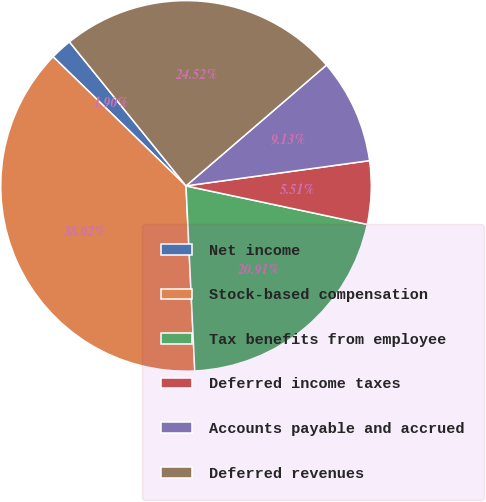Convert chart to OTSL. <chart><loc_0><loc_0><loc_500><loc_500><pie_chart><fcel>Net income<fcel>Stock-based compensation<fcel>Tax benefits from employee<fcel>Deferred income taxes<fcel>Accounts payable and accrued<fcel>Deferred revenues<nl><fcel>1.9%<fcel>38.02%<fcel>20.91%<fcel>5.51%<fcel>9.13%<fcel>24.52%<nl></chart> 